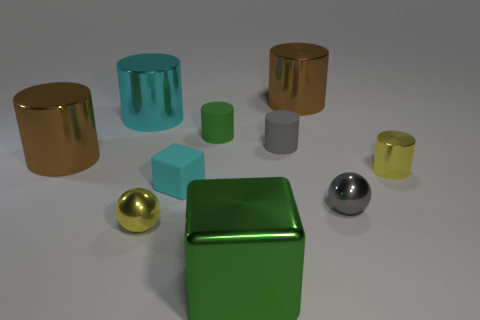Subtract all yellow spheres. How many brown cylinders are left? 2 Subtract all yellow cylinders. How many cylinders are left? 5 Subtract 2 cylinders. How many cylinders are left? 4 Subtract all big brown metallic cylinders. How many cylinders are left? 4 Subtract all gray cylinders. Subtract all red spheres. How many cylinders are left? 5 Subtract all cubes. How many objects are left? 8 Subtract 0 purple blocks. How many objects are left? 10 Subtract all big gray metallic blocks. Subtract all green matte cylinders. How many objects are left? 9 Add 1 cyan shiny cylinders. How many cyan shiny cylinders are left? 2 Add 5 big brown cylinders. How many big brown cylinders exist? 7 